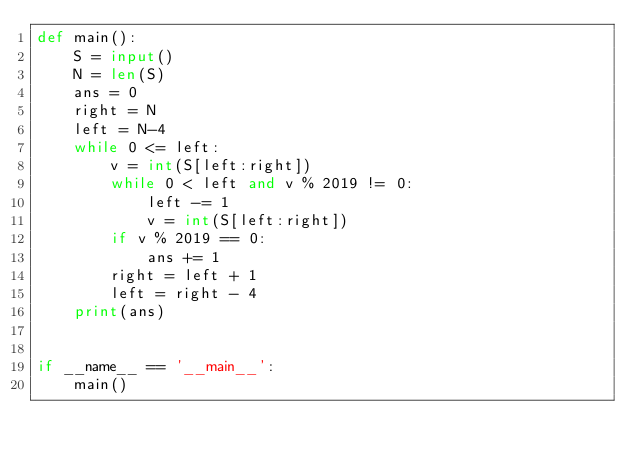<code> <loc_0><loc_0><loc_500><loc_500><_Python_>def main():
    S = input()
    N = len(S)
    ans = 0
    right = N
    left = N-4
    while 0 <= left:
        v = int(S[left:right])
        while 0 < left and v % 2019 != 0:
            left -= 1
            v = int(S[left:right])
        if v % 2019 == 0:
            ans += 1
        right = left + 1
        left = right - 4
    print(ans)


if __name__ == '__main__':
    main()
</code> 